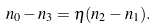Convert formula to latex. <formula><loc_0><loc_0><loc_500><loc_500>n _ { 0 } - n _ { 3 } = \eta ( n _ { 2 } - n _ { 1 } ) .</formula> 